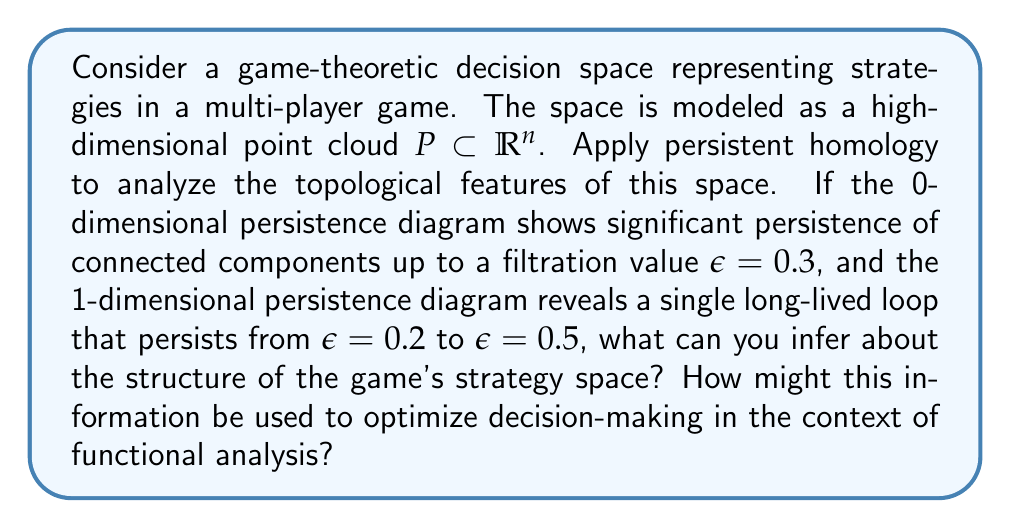Could you help me with this problem? To answer this question, we need to understand the principles of topological data analysis (TDA) and persistent homology, and how they can be applied to game theory:

1. Topological Data Analysis in Game Theory:
   TDA techniques, particularly persistent homology, can be used to analyze the structure of high-dimensional data. In game theory, the strategy space can be represented as a point cloud in high-dimensional space.

2. Interpreting Persistence Diagrams:
   - 0-dimensional persistence diagram: Represents the birth and death of connected components.
   - 1-dimensional persistence diagram: Represents the birth and death of loops or holes.

3. Analysis of the Given Information:
   a) 0-dimensional persistence:
      Significant persistence of connected components up to $\epsilon = 0.3$ suggests that the strategy space has multiple distinct clusters or regions that remain separated until the filtration value reaches 0.3.

   b) 1-dimensional persistence:
      A single long-lived loop persisting from $\epsilon = 0.2$ to $\epsilon = 0.5$ indicates a circular or cyclic structure in the strategy space.

4. Interpretation in Game Theory Context:
   - The distinct clusters (0-dimensional features) could represent different strategic approaches or "schools of thought" in the game.
   - The persistent loop (1-dimensional feature) might indicate a cyclic relationship between strategies, where strategies form a continuum that loops back on itself.

5. Application of Functional Analysis:
   Functional analysis can be applied to this topological structure to optimize decision-making:
   
   a) Use basis functions to represent the strategy space:
      $$\phi_i: P \to \mathbb{R}, i = 1,\ldots,m$$
   
   b) Construct a functional representing the game's payoff:
      $$F[\phi] = \int_P f(\phi(x)) dx$$
   
   c) Optimize the functional using variational methods, taking into account the topological constraints revealed by persistent homology.

6. Optimization Strategy:
   - For the distinct clusters, develop separate optimization strategies for each cluster.
   - For the cyclic structure, use periodic basis functions or consider the strategy space as a manifold with periodic boundary conditions.

By combining the topological insights with functional analysis techniques, we can develop more sophisticated and topology-aware optimization algorithms for decision-making in the game.
Answer: The persistence diagrams suggest that the game's strategy space consists of multiple distinct strategic approaches (represented by persistent 0-dimensional features) and a cyclic relationship between strategies (represented by the persistent 1-dimensional feature). This topological structure can be leveraged in functional analysis by using appropriate basis functions and optimization techniques that respect the clustered and cyclic nature of the strategy space, potentially leading to more effective decision-making algorithms in the game. 